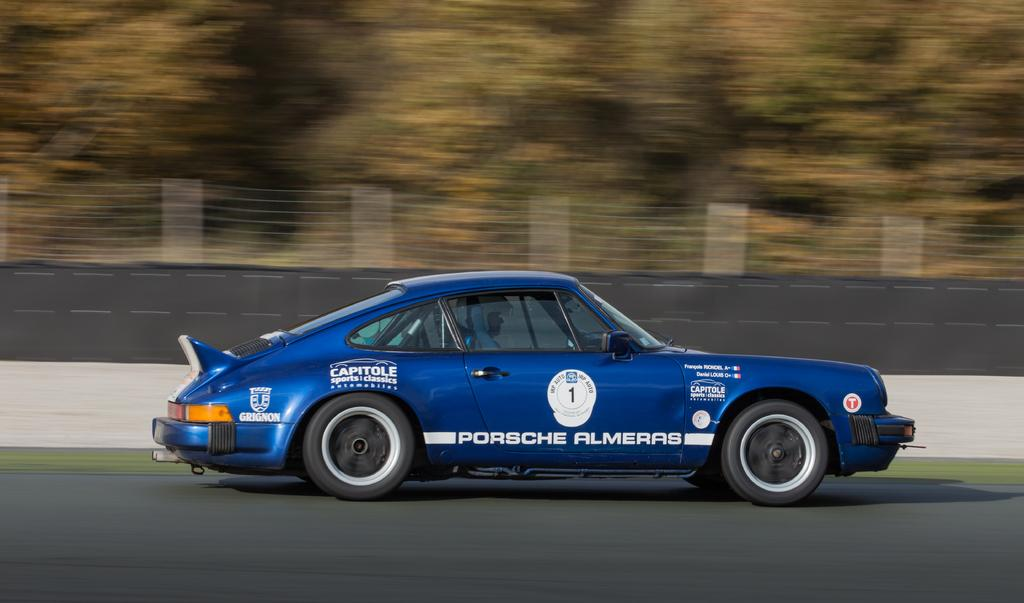What is the main subject of the image? There is a car in the image. Where is the car located? The car is standing on the road. What color is the car? The car is blue in color. Is there anyone inside the car? Yes, there is a person sitting in the car. What safety precaution is the person taking? The person is wearing a helmet. What type of silver object is the person holding in the image? There is no silver object present in the image. What emotion is the person expressing while sitting in the car? The image does not provide information about the person's emotions. 